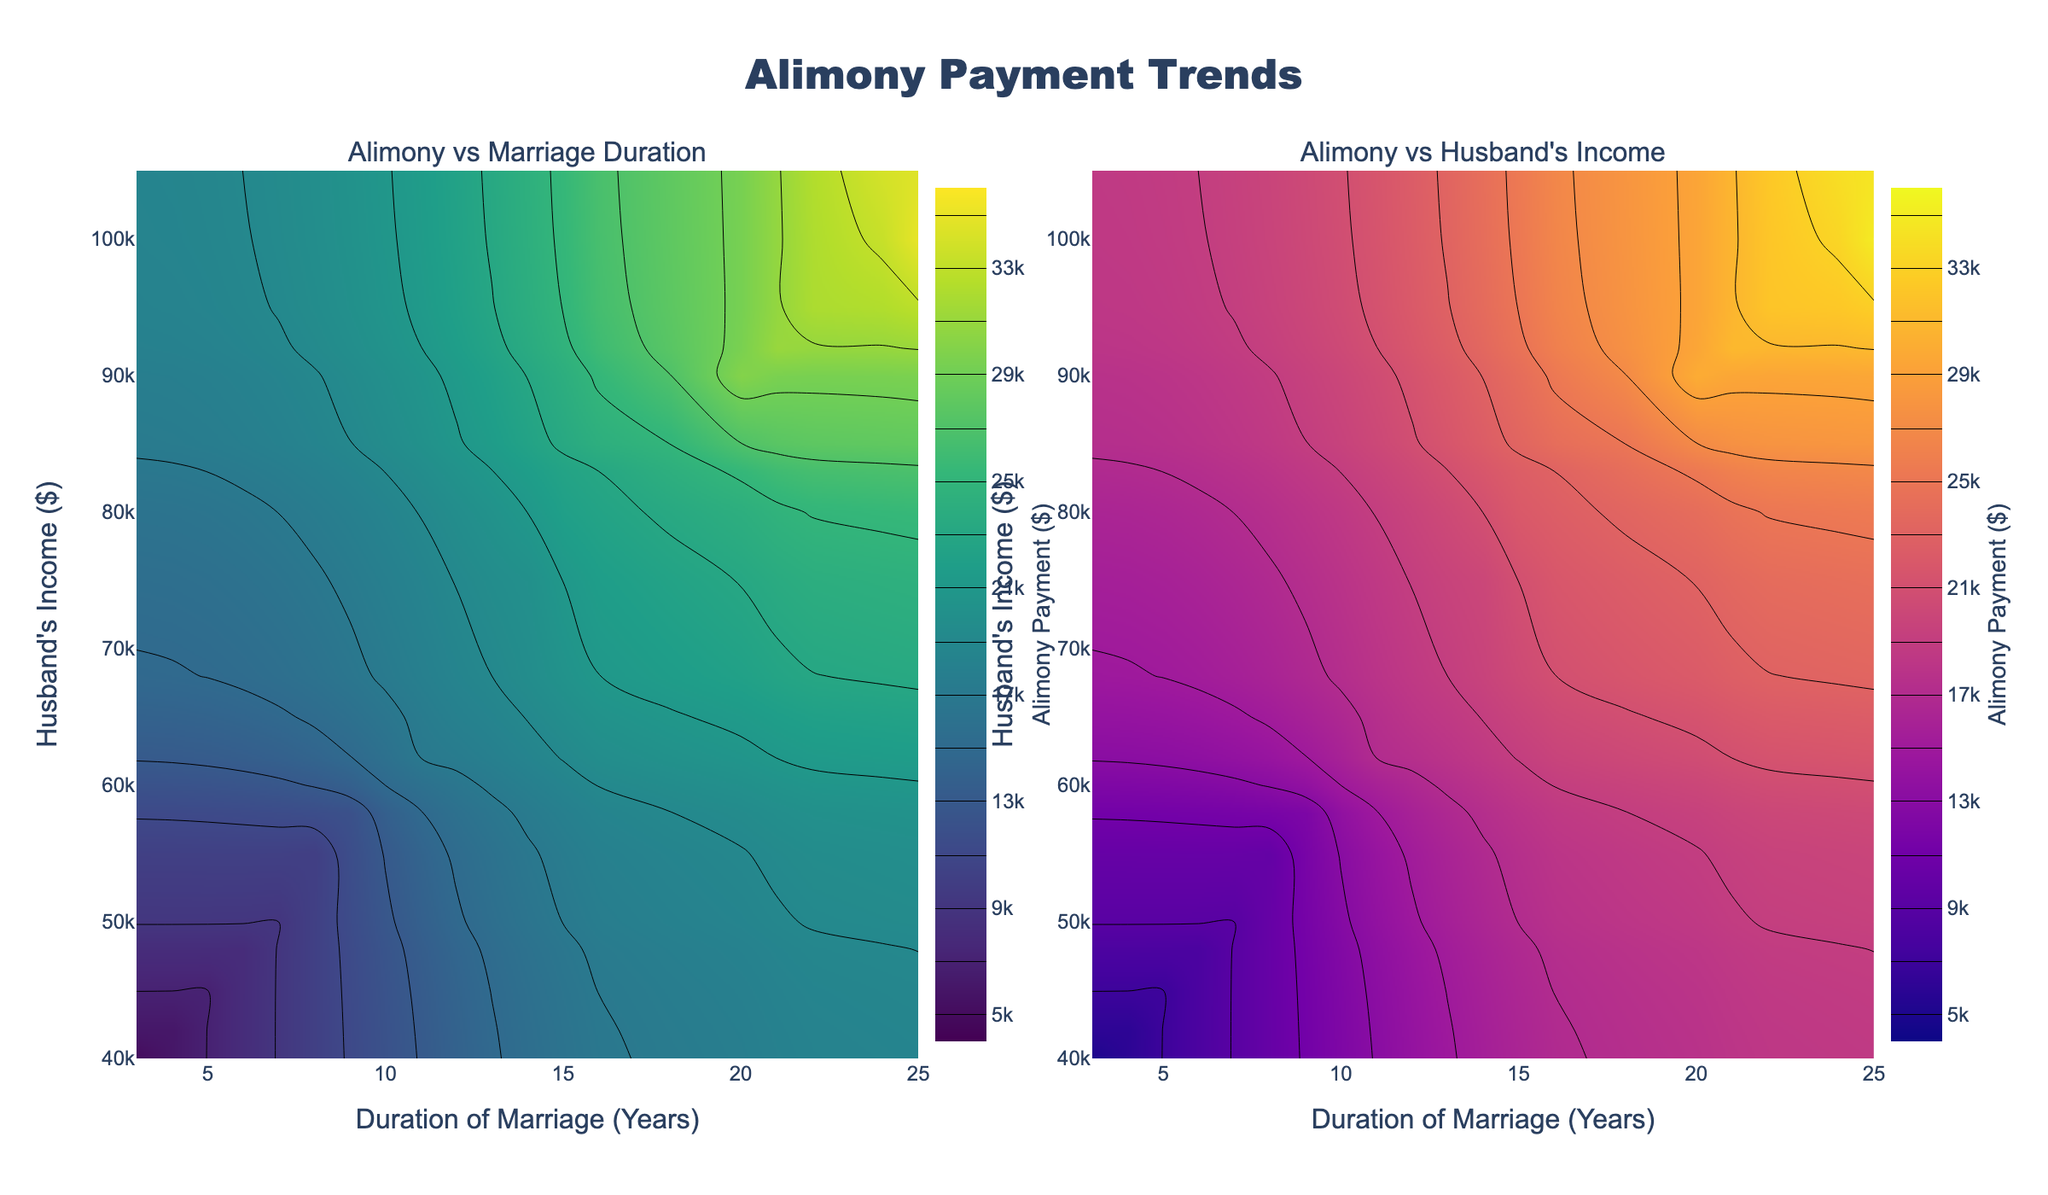How does the alimony payment trend change with increasing duration of marriage? By examining the left subplot on alimony vs. marriage duration, the contour lines indicate that alimony payments increase as the duration of marriage increases. For example, shorter marriages (e.g., 3-4 years) are associated with lower alimony payments (~5000-7000), whereas longer marriages (e.g., 20-25 years) are associated with higher alimony payments (~30000-35000).
Answer: Alimony payments increase with the duration of marriage How does the husband's income correlate with alimony payments according to the plot? Observing the right subplot on alimony vs. husband's income, the contour lines show a clear trend that as the husband's income increases, the alimony payments also rise. For example, husbands earning around $40,000-$50,000 face lower alimony payments (~5000-10000), while those earning $90,000-$100,000 face higher payments (~30000-35000).
Answer: Alimony payments increase with husband's income Which color scheme represents the alimony payment trends with marriage duration in the figure? The left subplot (Alimony vs Marriage Duration) uses a Viridis color scale, characterized by shades transitioning from purple to greenish-yellow. This colorscheme is used to represent different alimony payments levels.
Answer: Viridis Which plot uses the Plasma color scale to represent the data? The right subplot (Alimony vs Husband's Income) employs the Plasma color scale, which ranges from dark purple to yellowish-white, to indicate various levels of alimony payments.
Answer: Alimony vs Husband's Income At what combination of marriage duration and husband's income do alimony payments reach the maximum level according to the plots? By examining both subplots, the maximum alimony payments (~$35,000) occur around a 25-year marriage duration and a husband's income of about $100,000. The contour lines in both plots converge to these conditions.
Answer: 25 years and $100,000 What is the approximate alimony payment for a marriage duration of 10 years and a husband's income of $60,000? Referring to the contour lines on both subplots, for a marriage duration of 10 years and a husband's income of $60,000, the alimony payment is approximately around $15,000. This value is where the respective contour lines intersect.
Answer: ~$15,000 Is there a direct relationship between marriage duration and alimony payments when the husband's income is constant? By analyzing the contour lines in the left subplot while keeping the husband's income constant, the relationship shows that longer marriage durations are associated with higher alimony payments, indicating a direct relationship.
Answer: Yes How do the alimony payments compare for a husband earning $80,000 at marriage durations of 15 years vs 14 years? Observing the contour lines near $80,000 in the right subplot, for a 15-year marriage duration, the alimony payment is approximately $22,000, while for 14 years, it is about $20,000. This shows that alimony increases slightly as the marriage duration increases by one year.
Answer: $22,000 vs $20,000 What is the title of this figure? The title of the figure, located at the top center, is "Alimony Payment Trends." This title encompasses the content displayed in both subplots.
Answer: Alimony Payment Trends At a marriage duration of 6 years, what is the approximate range of alimony payments for varying husband's incomes? By analyzing the contour lines around the 6-year mark in both subplots, the range of alimony payments for different husband's incomes (approximately $48,000) is from $8,000 to $10,000.
Answer: ~$8,000 to ~$10,000 